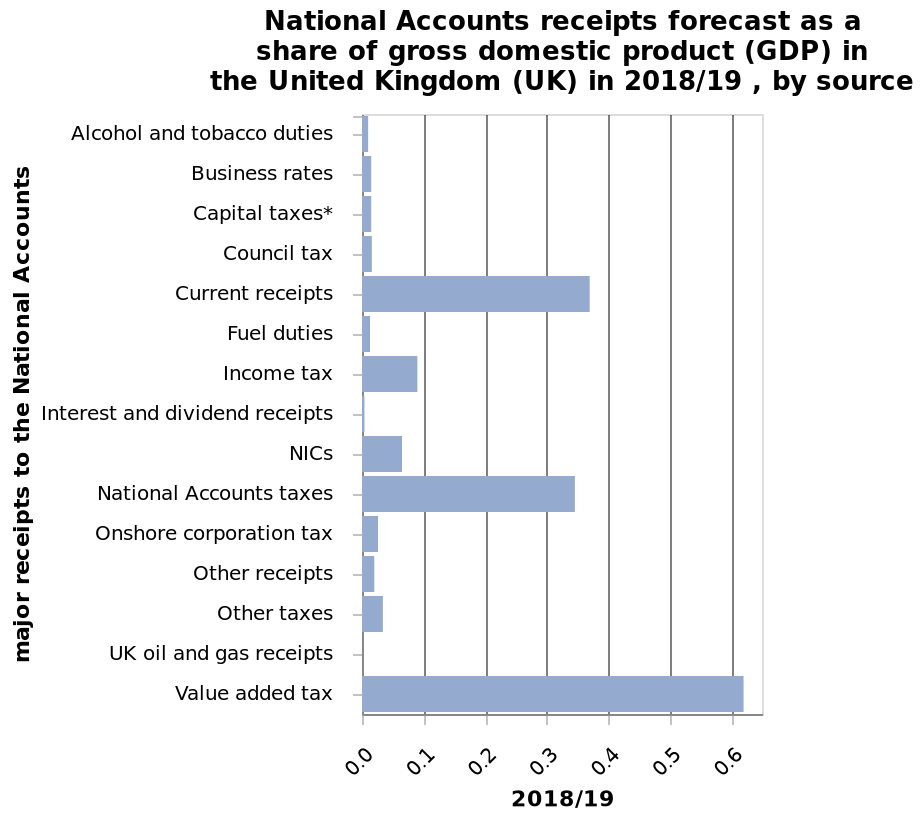<image>
What is represented on the x-axis of the bar chart? The x-axis of the bar chart represents the year 2018/19. What was the highest share of GDP in 2018/2019?  VAT What time period does the data in the bar chart correspond to? The data in the bar chart corresponds to the forecasted receipts as a share of GDP in the United Kingdom (UK) for the year 2018/19. Which category follows national accounts taxes in terms of its share in GDP? Other receipts 